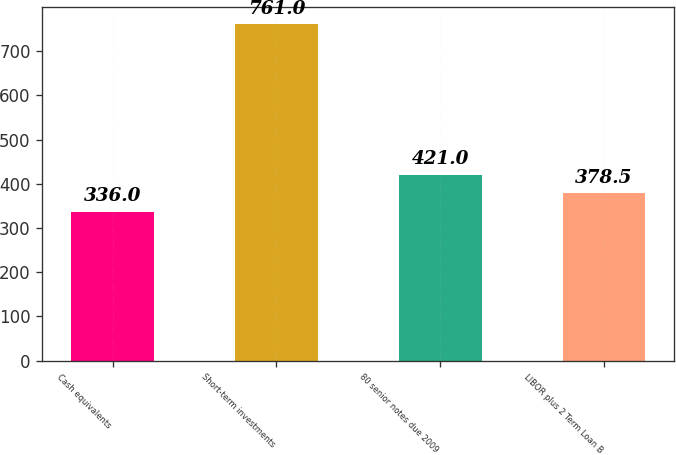Convert chart. <chart><loc_0><loc_0><loc_500><loc_500><bar_chart><fcel>Cash equivalents<fcel>Short-term investments<fcel>80 senior notes due 2009<fcel>LIBOR plus 2 Term Loan B<nl><fcel>336<fcel>761<fcel>421<fcel>378.5<nl></chart> 